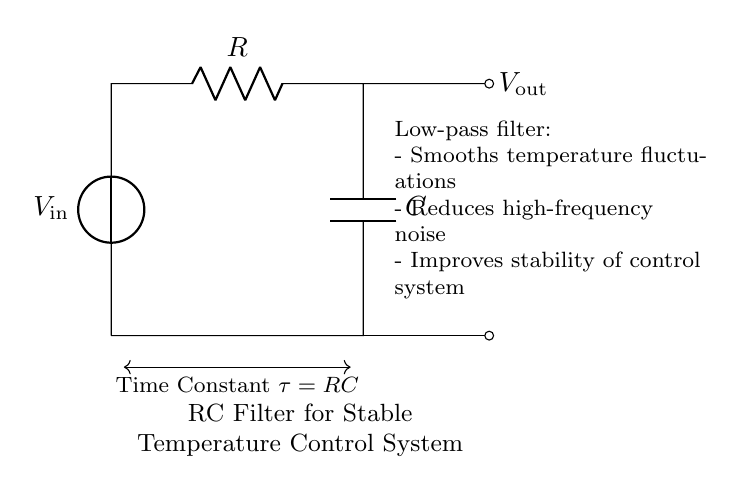What is the input voltage in the circuit? The input voltage is labeled as V_in, which indicates the voltage source at the top of the circuit diagram.
Answer: V_in What is the role of the capacitor in this circuit? The capacitor is used in conjunction with the resistor to form a low-pass filter that smooths temperature fluctuations by allowing low-frequency signals to pass while attenuating high-frequency signals.
Answer: Low-pass filter What is the time constant of the circuit? The time constant, denoted by τ, is given by the product of the resistance (R) and the capacitance (C): τ = R * C, indicating how quickly the circuit responds to voltage changes.
Answer: RC What happens to the output voltage as the input voltage decreases? As the input voltage decreases, the output voltage will also decrease, but at a slower rate due to the filtering effect of the resistor and capacitor, resulting in a more stable output.
Answer: Decreases How does this circuit improve the stability of the control system? By smoothing out rapid changes in the input voltage, the RC filter prevents sudden fluctuations from affecting the output voltage, leading to a more stable control system for temperature regulation.
Answer: Improves stability What component reduces high-frequency noise in the circuit? The capacitor, in its role within the RC filter, blocks high-frequency noise while allowing lower frequency signals (such as the desired temperature changes) to pass through.
Answer: Capacitor 